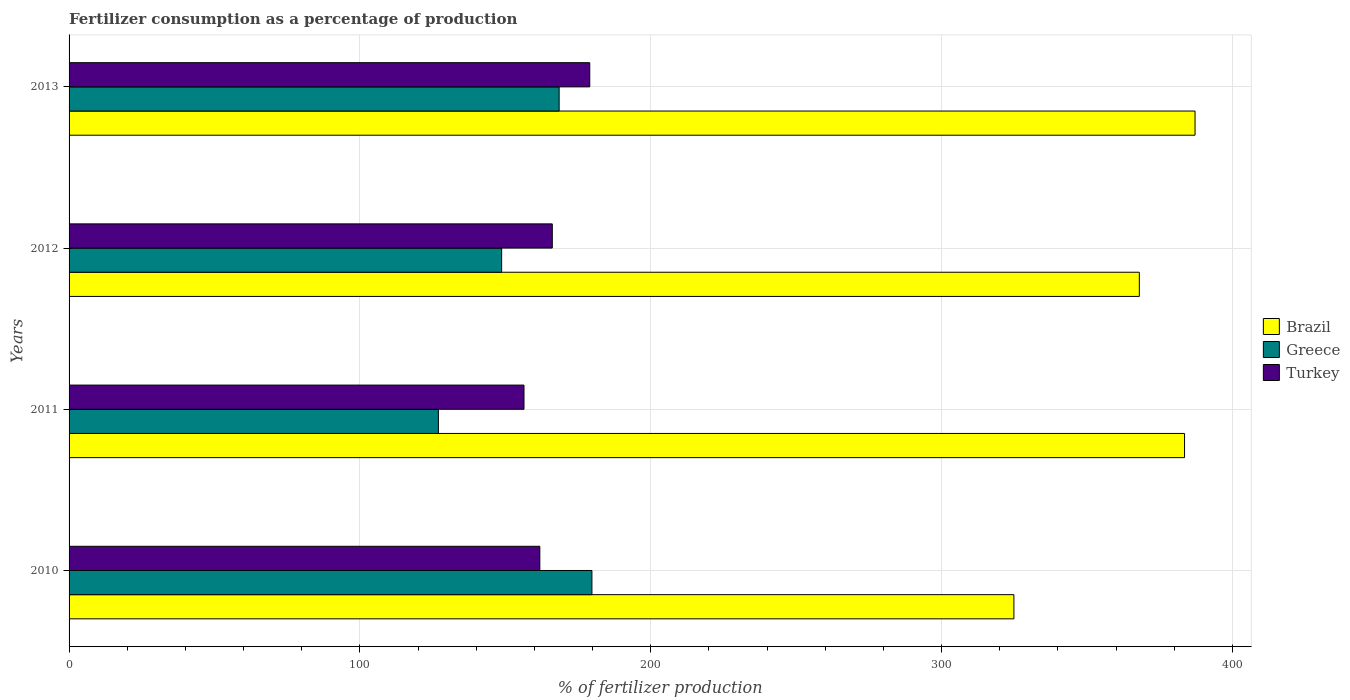How many different coloured bars are there?
Provide a succinct answer. 3. Are the number of bars per tick equal to the number of legend labels?
Your response must be concise. Yes. Are the number of bars on each tick of the Y-axis equal?
Ensure brevity in your answer.  Yes. How many bars are there on the 2nd tick from the top?
Keep it short and to the point. 3. How many bars are there on the 4th tick from the bottom?
Give a very brief answer. 3. In how many cases, is the number of bars for a given year not equal to the number of legend labels?
Your answer should be compact. 0. What is the percentage of fertilizers consumed in Turkey in 2013?
Your answer should be compact. 179.03. Across all years, what is the maximum percentage of fertilizers consumed in Brazil?
Provide a short and direct response. 387.15. Across all years, what is the minimum percentage of fertilizers consumed in Greece?
Provide a succinct answer. 126.98. What is the total percentage of fertilizers consumed in Turkey in the graph?
Offer a very short reply. 663.46. What is the difference between the percentage of fertilizers consumed in Brazil in 2012 and that in 2013?
Provide a succinct answer. -19.16. What is the difference between the percentage of fertilizers consumed in Brazil in 2011 and the percentage of fertilizers consumed in Turkey in 2013?
Keep it short and to the point. 204.51. What is the average percentage of fertilizers consumed in Turkey per year?
Your answer should be compact. 165.86. In the year 2011, what is the difference between the percentage of fertilizers consumed in Turkey and percentage of fertilizers consumed in Brazil?
Give a very brief answer. -227.12. What is the ratio of the percentage of fertilizers consumed in Brazil in 2010 to that in 2013?
Ensure brevity in your answer.  0.84. Is the percentage of fertilizers consumed in Brazil in 2010 less than that in 2013?
Provide a succinct answer. Yes. Is the difference between the percentage of fertilizers consumed in Turkey in 2010 and 2012 greater than the difference between the percentage of fertilizers consumed in Brazil in 2010 and 2012?
Make the answer very short. Yes. What is the difference between the highest and the second highest percentage of fertilizers consumed in Greece?
Keep it short and to the point. 11.27. What is the difference between the highest and the lowest percentage of fertilizers consumed in Brazil?
Offer a very short reply. 62.28. In how many years, is the percentage of fertilizers consumed in Brazil greater than the average percentage of fertilizers consumed in Brazil taken over all years?
Provide a short and direct response. 3. Is the sum of the percentage of fertilizers consumed in Greece in 2010 and 2012 greater than the maximum percentage of fertilizers consumed in Turkey across all years?
Your answer should be very brief. Yes. What does the 1st bar from the top in 2013 represents?
Your answer should be very brief. Turkey. How many bars are there?
Your answer should be compact. 12. Are all the bars in the graph horizontal?
Provide a succinct answer. Yes. What is the difference between two consecutive major ticks on the X-axis?
Provide a short and direct response. 100. Are the values on the major ticks of X-axis written in scientific E-notation?
Provide a short and direct response. No. How many legend labels are there?
Your response must be concise. 3. What is the title of the graph?
Offer a terse response. Fertilizer consumption as a percentage of production. Does "Morocco" appear as one of the legend labels in the graph?
Offer a terse response. No. What is the label or title of the X-axis?
Your answer should be very brief. % of fertilizer production. What is the label or title of the Y-axis?
Offer a terse response. Years. What is the % of fertilizer production of Brazil in 2010?
Provide a succinct answer. 324.87. What is the % of fertilizer production in Greece in 2010?
Your response must be concise. 179.77. What is the % of fertilizer production of Turkey in 2010?
Give a very brief answer. 161.86. What is the % of fertilizer production in Brazil in 2011?
Your answer should be compact. 383.54. What is the % of fertilizer production in Greece in 2011?
Your answer should be very brief. 126.98. What is the % of fertilizer production in Turkey in 2011?
Ensure brevity in your answer.  156.42. What is the % of fertilizer production of Brazil in 2012?
Your answer should be compact. 367.99. What is the % of fertilizer production of Greece in 2012?
Ensure brevity in your answer.  148.73. What is the % of fertilizer production in Turkey in 2012?
Your answer should be very brief. 166.15. What is the % of fertilizer production of Brazil in 2013?
Your answer should be compact. 387.15. What is the % of fertilizer production in Greece in 2013?
Your answer should be very brief. 168.5. What is the % of fertilizer production of Turkey in 2013?
Provide a succinct answer. 179.03. Across all years, what is the maximum % of fertilizer production in Brazil?
Ensure brevity in your answer.  387.15. Across all years, what is the maximum % of fertilizer production in Greece?
Make the answer very short. 179.77. Across all years, what is the maximum % of fertilizer production of Turkey?
Your response must be concise. 179.03. Across all years, what is the minimum % of fertilizer production in Brazil?
Your answer should be compact. 324.87. Across all years, what is the minimum % of fertilizer production of Greece?
Your answer should be compact. 126.98. Across all years, what is the minimum % of fertilizer production in Turkey?
Your response must be concise. 156.42. What is the total % of fertilizer production of Brazil in the graph?
Provide a short and direct response. 1463.55. What is the total % of fertilizer production of Greece in the graph?
Offer a terse response. 623.99. What is the total % of fertilizer production of Turkey in the graph?
Your answer should be compact. 663.46. What is the difference between the % of fertilizer production of Brazil in 2010 and that in 2011?
Give a very brief answer. -58.67. What is the difference between the % of fertilizer production of Greece in 2010 and that in 2011?
Make the answer very short. 52.79. What is the difference between the % of fertilizer production in Turkey in 2010 and that in 2011?
Your answer should be very brief. 5.44. What is the difference between the % of fertilizer production in Brazil in 2010 and that in 2012?
Your answer should be very brief. -43.12. What is the difference between the % of fertilizer production of Greece in 2010 and that in 2012?
Ensure brevity in your answer.  31.04. What is the difference between the % of fertilizer production of Turkey in 2010 and that in 2012?
Your answer should be very brief. -4.29. What is the difference between the % of fertilizer production in Brazil in 2010 and that in 2013?
Ensure brevity in your answer.  -62.28. What is the difference between the % of fertilizer production in Greece in 2010 and that in 2013?
Your answer should be very brief. 11.27. What is the difference between the % of fertilizer production in Turkey in 2010 and that in 2013?
Keep it short and to the point. -17.17. What is the difference between the % of fertilizer production in Brazil in 2011 and that in 2012?
Offer a terse response. 15.54. What is the difference between the % of fertilizer production of Greece in 2011 and that in 2012?
Offer a terse response. -21.75. What is the difference between the % of fertilizer production in Turkey in 2011 and that in 2012?
Give a very brief answer. -9.73. What is the difference between the % of fertilizer production in Brazil in 2011 and that in 2013?
Offer a very short reply. -3.61. What is the difference between the % of fertilizer production of Greece in 2011 and that in 2013?
Ensure brevity in your answer.  -41.52. What is the difference between the % of fertilizer production in Turkey in 2011 and that in 2013?
Make the answer very short. -22.61. What is the difference between the % of fertilizer production of Brazil in 2012 and that in 2013?
Keep it short and to the point. -19.16. What is the difference between the % of fertilizer production in Greece in 2012 and that in 2013?
Provide a succinct answer. -19.77. What is the difference between the % of fertilizer production of Turkey in 2012 and that in 2013?
Provide a short and direct response. -12.88. What is the difference between the % of fertilizer production in Brazil in 2010 and the % of fertilizer production in Greece in 2011?
Offer a very short reply. 197.88. What is the difference between the % of fertilizer production in Brazil in 2010 and the % of fertilizer production in Turkey in 2011?
Make the answer very short. 168.45. What is the difference between the % of fertilizer production of Greece in 2010 and the % of fertilizer production of Turkey in 2011?
Make the answer very short. 23.35. What is the difference between the % of fertilizer production of Brazil in 2010 and the % of fertilizer production of Greece in 2012?
Make the answer very short. 176.14. What is the difference between the % of fertilizer production of Brazil in 2010 and the % of fertilizer production of Turkey in 2012?
Your answer should be very brief. 158.72. What is the difference between the % of fertilizer production of Greece in 2010 and the % of fertilizer production of Turkey in 2012?
Give a very brief answer. 13.62. What is the difference between the % of fertilizer production of Brazil in 2010 and the % of fertilizer production of Greece in 2013?
Keep it short and to the point. 156.37. What is the difference between the % of fertilizer production in Brazil in 2010 and the % of fertilizer production in Turkey in 2013?
Your answer should be very brief. 145.84. What is the difference between the % of fertilizer production of Greece in 2010 and the % of fertilizer production of Turkey in 2013?
Your answer should be compact. 0.75. What is the difference between the % of fertilizer production of Brazil in 2011 and the % of fertilizer production of Greece in 2012?
Offer a terse response. 234.8. What is the difference between the % of fertilizer production of Brazil in 2011 and the % of fertilizer production of Turkey in 2012?
Make the answer very short. 217.39. What is the difference between the % of fertilizer production of Greece in 2011 and the % of fertilizer production of Turkey in 2012?
Ensure brevity in your answer.  -39.17. What is the difference between the % of fertilizer production of Brazil in 2011 and the % of fertilizer production of Greece in 2013?
Ensure brevity in your answer.  215.03. What is the difference between the % of fertilizer production of Brazil in 2011 and the % of fertilizer production of Turkey in 2013?
Offer a terse response. 204.51. What is the difference between the % of fertilizer production of Greece in 2011 and the % of fertilizer production of Turkey in 2013?
Keep it short and to the point. -52.04. What is the difference between the % of fertilizer production in Brazil in 2012 and the % of fertilizer production in Greece in 2013?
Your response must be concise. 199.49. What is the difference between the % of fertilizer production of Brazil in 2012 and the % of fertilizer production of Turkey in 2013?
Your answer should be compact. 188.96. What is the difference between the % of fertilizer production in Greece in 2012 and the % of fertilizer production in Turkey in 2013?
Your answer should be compact. -30.3. What is the average % of fertilizer production in Brazil per year?
Ensure brevity in your answer.  365.89. What is the average % of fertilizer production of Greece per year?
Your answer should be very brief. 156. What is the average % of fertilizer production of Turkey per year?
Ensure brevity in your answer.  165.86. In the year 2010, what is the difference between the % of fertilizer production of Brazil and % of fertilizer production of Greece?
Give a very brief answer. 145.1. In the year 2010, what is the difference between the % of fertilizer production in Brazil and % of fertilizer production in Turkey?
Your answer should be very brief. 163.01. In the year 2010, what is the difference between the % of fertilizer production of Greece and % of fertilizer production of Turkey?
Give a very brief answer. 17.91. In the year 2011, what is the difference between the % of fertilizer production of Brazil and % of fertilizer production of Greece?
Provide a succinct answer. 256.55. In the year 2011, what is the difference between the % of fertilizer production in Brazil and % of fertilizer production in Turkey?
Offer a very short reply. 227.12. In the year 2011, what is the difference between the % of fertilizer production of Greece and % of fertilizer production of Turkey?
Your response must be concise. -29.43. In the year 2012, what is the difference between the % of fertilizer production of Brazil and % of fertilizer production of Greece?
Keep it short and to the point. 219.26. In the year 2012, what is the difference between the % of fertilizer production in Brazil and % of fertilizer production in Turkey?
Ensure brevity in your answer.  201.84. In the year 2012, what is the difference between the % of fertilizer production of Greece and % of fertilizer production of Turkey?
Provide a short and direct response. -17.42. In the year 2013, what is the difference between the % of fertilizer production of Brazil and % of fertilizer production of Greece?
Offer a terse response. 218.65. In the year 2013, what is the difference between the % of fertilizer production of Brazil and % of fertilizer production of Turkey?
Provide a succinct answer. 208.12. In the year 2013, what is the difference between the % of fertilizer production of Greece and % of fertilizer production of Turkey?
Provide a succinct answer. -10.52. What is the ratio of the % of fertilizer production in Brazil in 2010 to that in 2011?
Keep it short and to the point. 0.85. What is the ratio of the % of fertilizer production in Greece in 2010 to that in 2011?
Your response must be concise. 1.42. What is the ratio of the % of fertilizer production in Turkey in 2010 to that in 2011?
Offer a very short reply. 1.03. What is the ratio of the % of fertilizer production of Brazil in 2010 to that in 2012?
Offer a very short reply. 0.88. What is the ratio of the % of fertilizer production in Greece in 2010 to that in 2012?
Ensure brevity in your answer.  1.21. What is the ratio of the % of fertilizer production in Turkey in 2010 to that in 2012?
Your answer should be compact. 0.97. What is the ratio of the % of fertilizer production of Brazil in 2010 to that in 2013?
Ensure brevity in your answer.  0.84. What is the ratio of the % of fertilizer production of Greece in 2010 to that in 2013?
Offer a very short reply. 1.07. What is the ratio of the % of fertilizer production of Turkey in 2010 to that in 2013?
Offer a very short reply. 0.9. What is the ratio of the % of fertilizer production in Brazil in 2011 to that in 2012?
Your answer should be compact. 1.04. What is the ratio of the % of fertilizer production in Greece in 2011 to that in 2012?
Make the answer very short. 0.85. What is the ratio of the % of fertilizer production in Turkey in 2011 to that in 2012?
Your answer should be very brief. 0.94. What is the ratio of the % of fertilizer production of Greece in 2011 to that in 2013?
Give a very brief answer. 0.75. What is the ratio of the % of fertilizer production in Turkey in 2011 to that in 2013?
Offer a very short reply. 0.87. What is the ratio of the % of fertilizer production of Brazil in 2012 to that in 2013?
Offer a very short reply. 0.95. What is the ratio of the % of fertilizer production in Greece in 2012 to that in 2013?
Your answer should be very brief. 0.88. What is the ratio of the % of fertilizer production of Turkey in 2012 to that in 2013?
Provide a short and direct response. 0.93. What is the difference between the highest and the second highest % of fertilizer production of Brazil?
Provide a short and direct response. 3.61. What is the difference between the highest and the second highest % of fertilizer production in Greece?
Your answer should be very brief. 11.27. What is the difference between the highest and the second highest % of fertilizer production in Turkey?
Provide a succinct answer. 12.88. What is the difference between the highest and the lowest % of fertilizer production in Brazil?
Your response must be concise. 62.28. What is the difference between the highest and the lowest % of fertilizer production in Greece?
Ensure brevity in your answer.  52.79. What is the difference between the highest and the lowest % of fertilizer production in Turkey?
Provide a succinct answer. 22.61. 